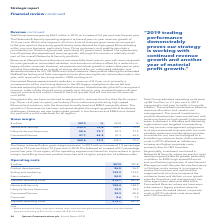According to Spirent Communications Plc's financial document, What was the gross margin in 2019? According to the financial document, 368.6 (in millions). The relevant text states: "368.6 73.2 344.5 72.2..." Also, What was the gross margin in 2018? According to the financial document, 344.5 (in millions). The relevant text states: "368.6 73.2 344.5 72.2..." Also, Which operating segments in the table achieved an improvement in gross margin? The document contains multiple relevant values: Networks & Security, Lifecycle Service Assurance, Connected Devices. From the document: "Networks & Security 232.3 72.6 205.3 72.0 Lifecycle Service Assurance 88.6 79.7 87.9 77.9 Connected Devices 47.7 65.8 51.3 64.9..." Additionally, In which year was the amount of gross profit for Connected Devices larger? According to the financial document, 2018. The relevant text states: "$ million 2019 % 2018 %..." Also, can you calculate: What was the change in the amount of gross profits? Based on the calculation: 368.6-344.5, the result is 24.1 (in millions). This is based on the information: "368.6 73.2 344.5 72.2 368.6 73.2 344.5 72.2..." The key data points involved are: 344.5, 368.6. Also, can you calculate: What was the percentage change in the amount of gross profits? To answer this question, I need to perform calculations using the financial data. The calculation is: (368.6-344.5)/344.5, which equals 7 (percentage). This is based on the information: "368.6 73.2 344.5 72.2 368.6 73.2 344.5 72.2..." The key data points involved are: 344.5, 368.6. 